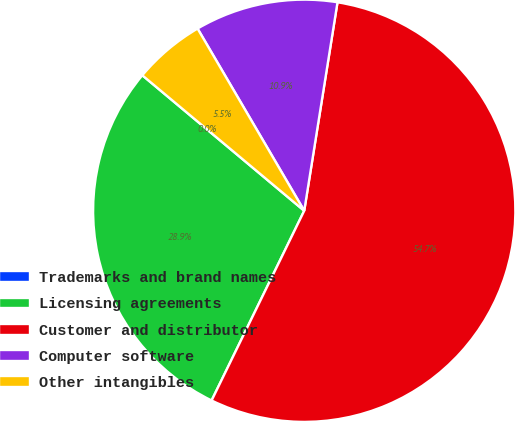Convert chart. <chart><loc_0><loc_0><loc_500><loc_500><pie_chart><fcel>Trademarks and brand names<fcel>Licensing agreements<fcel>Customer and distributor<fcel>Computer software<fcel>Other intangibles<nl><fcel>0.0%<fcel>28.86%<fcel>54.71%<fcel>10.95%<fcel>5.48%<nl></chart> 